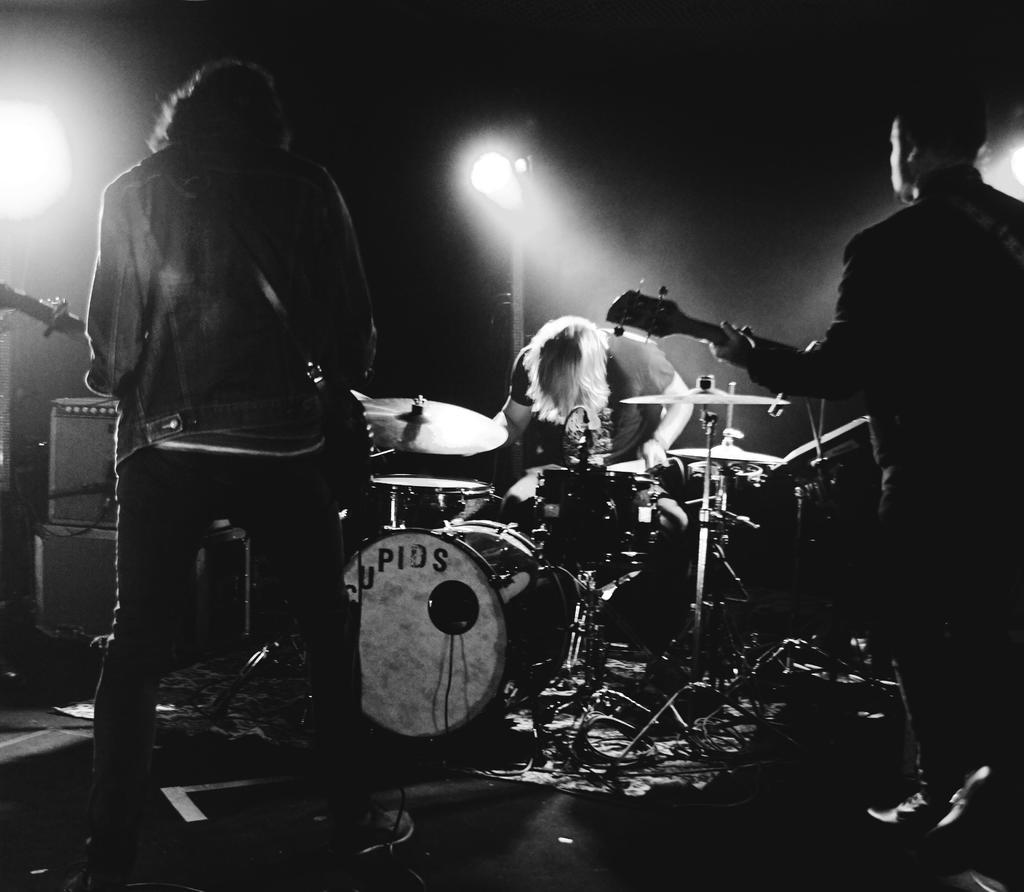How many people are playing musical instruments in the image? There are three persons playing musical instruments in the image. What can be seen in the background of the image? There is a light pole in the background of the image. What channel is the throne featured on in the image? There is no throne or channel present in the image; it features three persons playing musical instruments and a light pole in the background. 